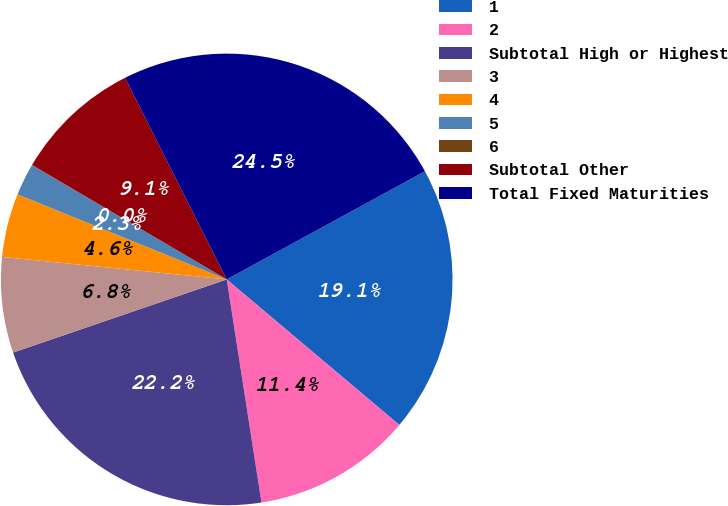Convert chart. <chart><loc_0><loc_0><loc_500><loc_500><pie_chart><fcel>1<fcel>2<fcel>Subtotal High or Highest<fcel>3<fcel>4<fcel>5<fcel>6<fcel>Subtotal Other<fcel>Total Fixed Maturities<nl><fcel>19.1%<fcel>11.39%<fcel>22.21%<fcel>6.84%<fcel>4.56%<fcel>2.29%<fcel>0.02%<fcel>9.11%<fcel>24.48%<nl></chart> 